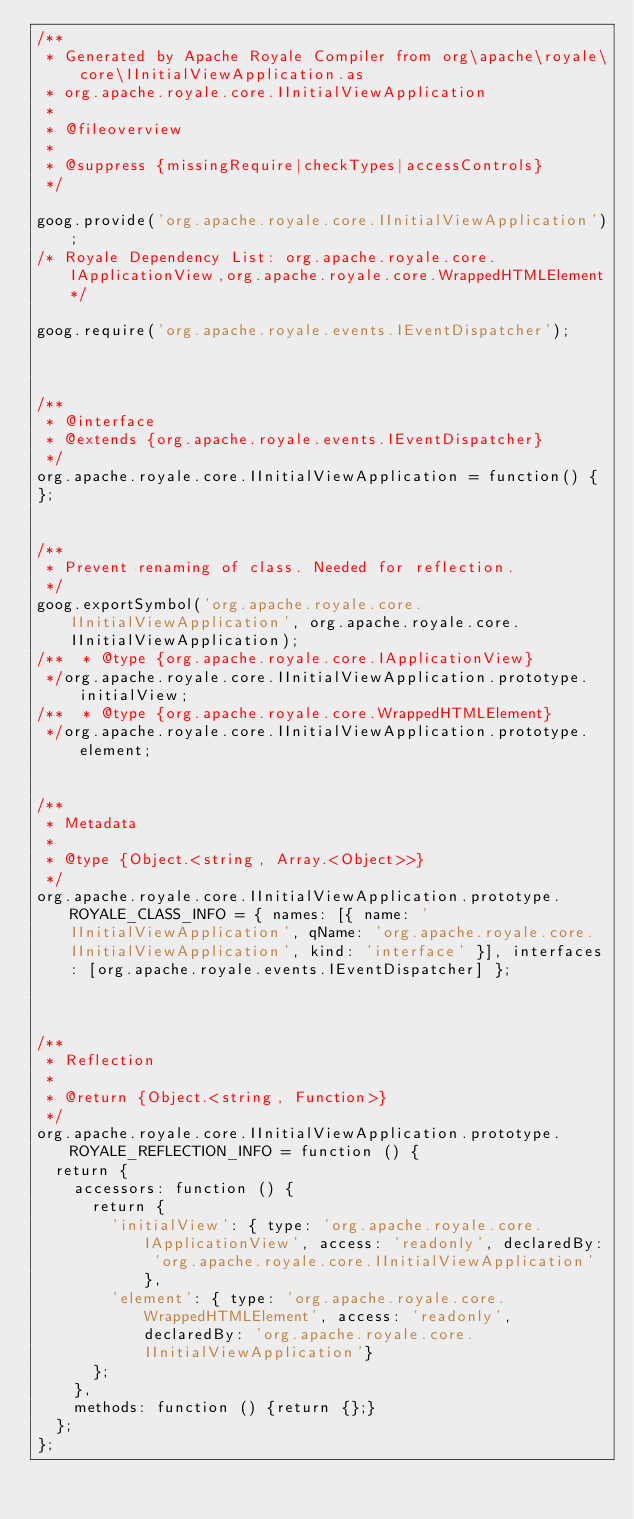Convert code to text. <code><loc_0><loc_0><loc_500><loc_500><_JavaScript_>/**
 * Generated by Apache Royale Compiler from org\apache\royale\core\IInitialViewApplication.as
 * org.apache.royale.core.IInitialViewApplication
 *
 * @fileoverview
 *
 * @suppress {missingRequire|checkTypes|accessControls}
 */

goog.provide('org.apache.royale.core.IInitialViewApplication');
/* Royale Dependency List: org.apache.royale.core.IApplicationView,org.apache.royale.core.WrappedHTMLElement*/

goog.require('org.apache.royale.events.IEventDispatcher');



/**
 * @interface
 * @extends {org.apache.royale.events.IEventDispatcher}
 */
org.apache.royale.core.IInitialViewApplication = function() {
};


/**
 * Prevent renaming of class. Needed for reflection.
 */
goog.exportSymbol('org.apache.royale.core.IInitialViewApplication', org.apache.royale.core.IInitialViewApplication);
/**  * @type {org.apache.royale.core.IApplicationView}
 */org.apache.royale.core.IInitialViewApplication.prototype.initialView;
/**  * @type {org.apache.royale.core.WrappedHTMLElement}
 */org.apache.royale.core.IInitialViewApplication.prototype.element;


/**
 * Metadata
 *
 * @type {Object.<string, Array.<Object>>}
 */
org.apache.royale.core.IInitialViewApplication.prototype.ROYALE_CLASS_INFO = { names: [{ name: 'IInitialViewApplication', qName: 'org.apache.royale.core.IInitialViewApplication', kind: 'interface' }], interfaces: [org.apache.royale.events.IEventDispatcher] };



/**
 * Reflection
 *
 * @return {Object.<string, Function>}
 */
org.apache.royale.core.IInitialViewApplication.prototype.ROYALE_REFLECTION_INFO = function () {
  return {
    accessors: function () {
      return {
        'initialView': { type: 'org.apache.royale.core.IApplicationView', access: 'readonly', declaredBy: 'org.apache.royale.core.IInitialViewApplication'},
        'element': { type: 'org.apache.royale.core.WrappedHTMLElement', access: 'readonly', declaredBy: 'org.apache.royale.core.IInitialViewApplication'}
      };
    },
    methods: function () {return {};}
  };
};
</code> 